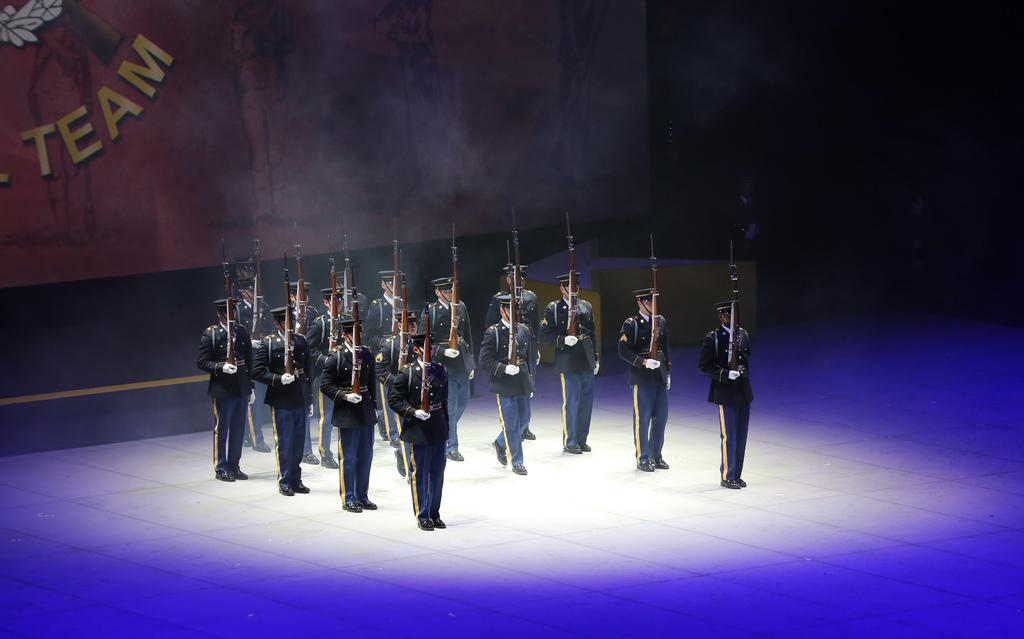What are the people in the center of the image holding? The people in the center of the image are holding guns. What can be seen in the background of the image? There is a wall in the background of the image. What type of patch is visible on the wall in the image? There is no patch visible on the wall in the image. What type of wilderness can be seen in the background of the image? There is no wilderness present in the image; it features a wall in the background. 